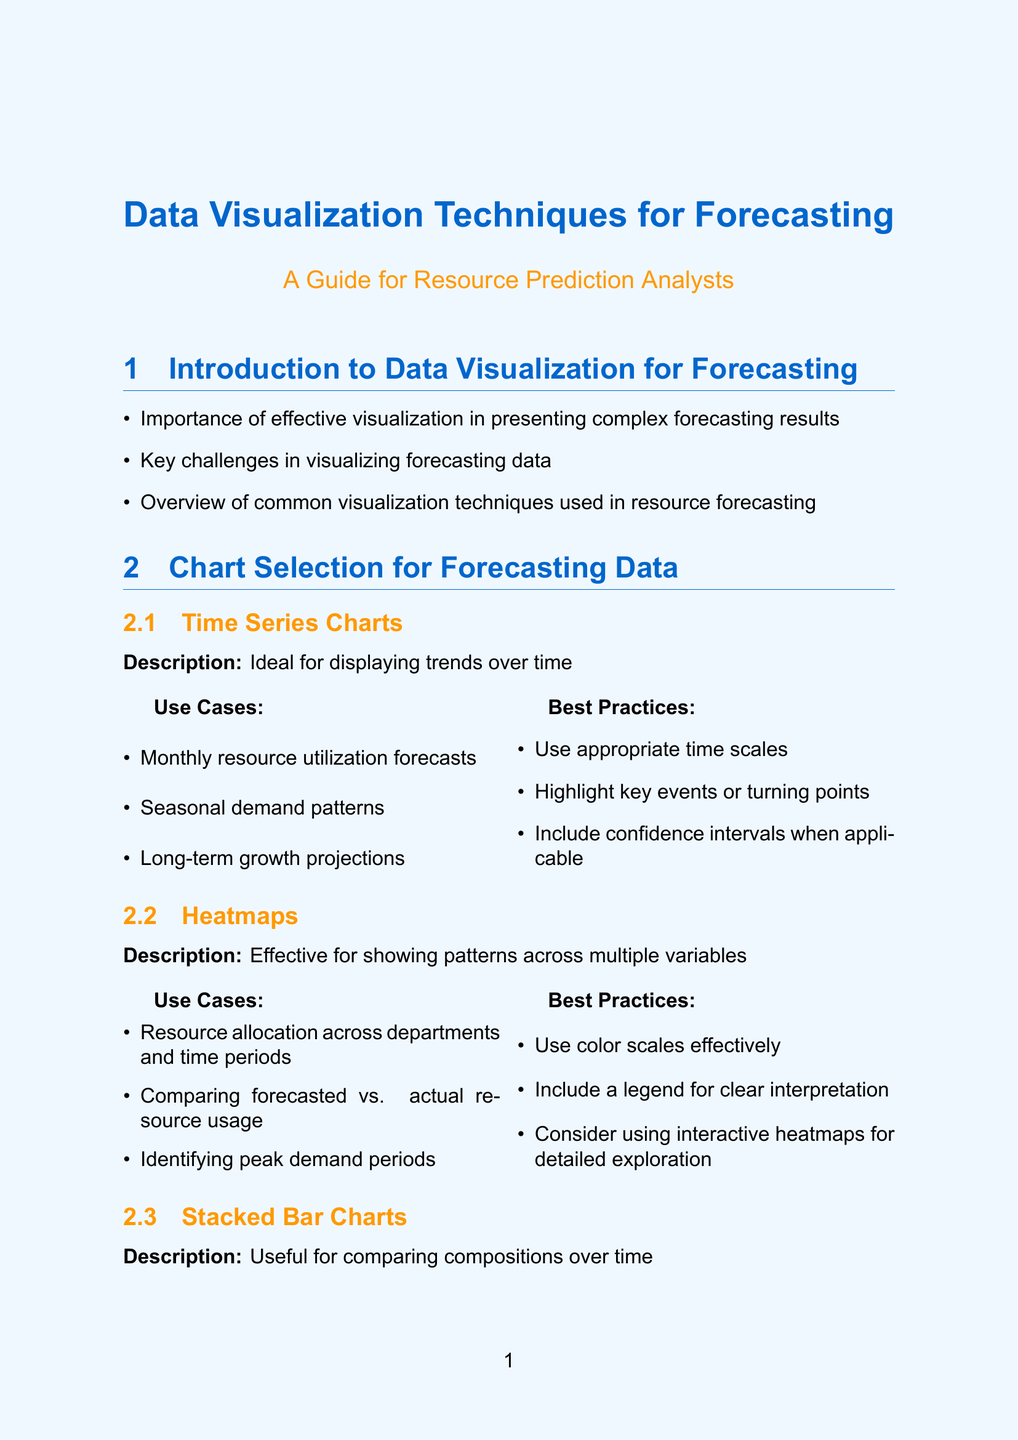What is the title of the manual? The title is stated at the beginning of the document, highlighting the main focus on visualization techniques.
Answer: Data Visualization Techniques for Forecasting What chart type is ideal for displaying trends over time? The document specifies various chart types, indicating which is suited for trends over periods.
Answer: Time Series Charts Which company used interactive dashboards for regional comparisons? The case studies section presents examples of companies and their visualization techniques.
Answer: Amazon What chart type is effective for showing patterns across multiple variables? This detail is included in the chart selection section, identifying the usefulness of specific charts.
Answer: Heatmaps What is one best practice for time series charts? The document lists guidelines for effective chart design, including recommendations for specific chart types.
Answer: Highlight key events or turning points Which techniques were used by General Electric for energy demand forecasting? This question requires synthesizing information from the case studies section about techniques utilized by the company.
Answer: Stacked area charts, Geospatial heatmaps, Probabilistic fan charts What tools are mentioned for creating interactive dashboards? The advanced visualization techniques section lists specific tools used for interactive visualizations.
Answer: Tableau, Power BI, D3.js What are the primary strengths of using R for forecasting visualization? The tools and software section outlines the strengths associated with different programming tools and their packages.
Answer: Statistical analysis and custom visualizations 